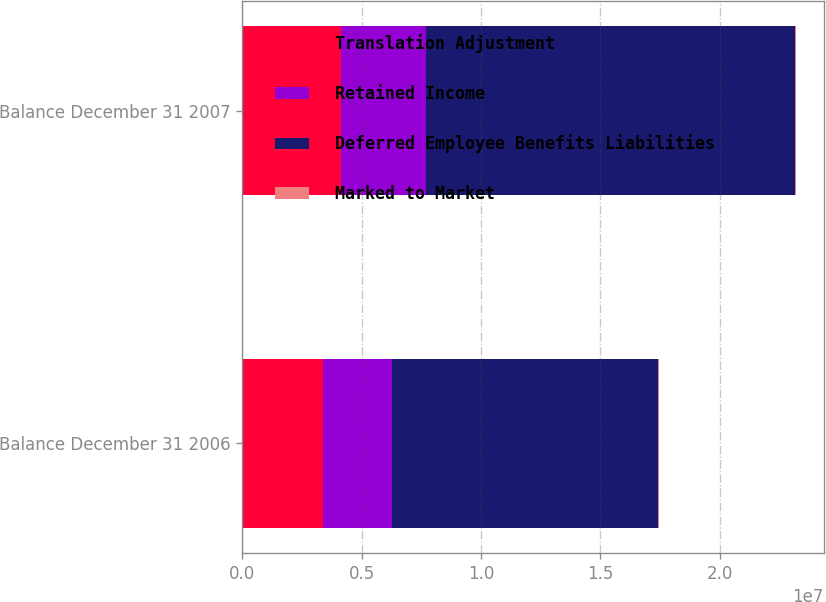<chart> <loc_0><loc_0><loc_500><loc_500><stacked_bar_chart><ecel><fcel>Balance December 31 2006<fcel>Balance December 31 2007<nl><fcel>Translation Adjustment<fcel>3.38195e+06<fcel>4.13636e+06<nl><fcel>Retained Income<fcel>2.91179e+06<fcel>3.54924e+06<nl><fcel>Deferred Employee Benefits Liabilities<fcel>1.11185e+07<fcel>1.54618e+07<nl><fcel>Marked to Market<fcel>20712<fcel>31627<nl></chart> 